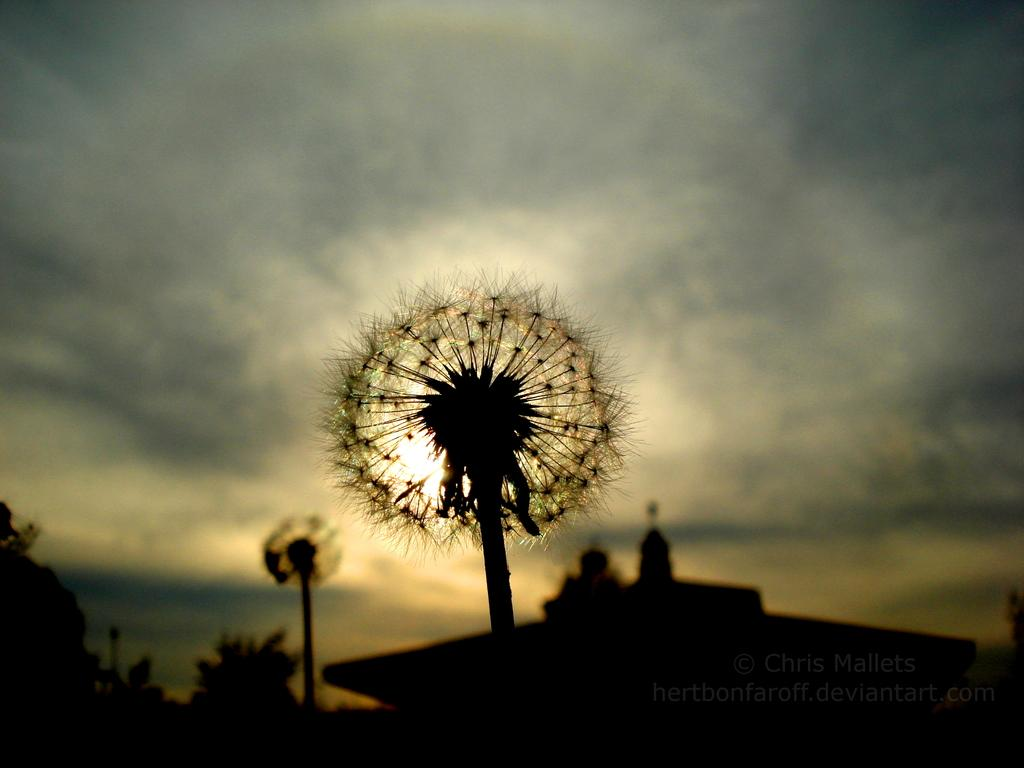What type of living organisms can be seen in the image? There are flowers in the image. What is the condition of the sky in the image? The sky is cloudy in the image. What color is the crayon used to draw the flowers in the image? There is no crayon present in the image, and the flowers are not depicted as being drawn. What type of shirt is the band wearing in the image? There is no band present in the image, so it's not possible to determine what type of shirt they might be wearing. 